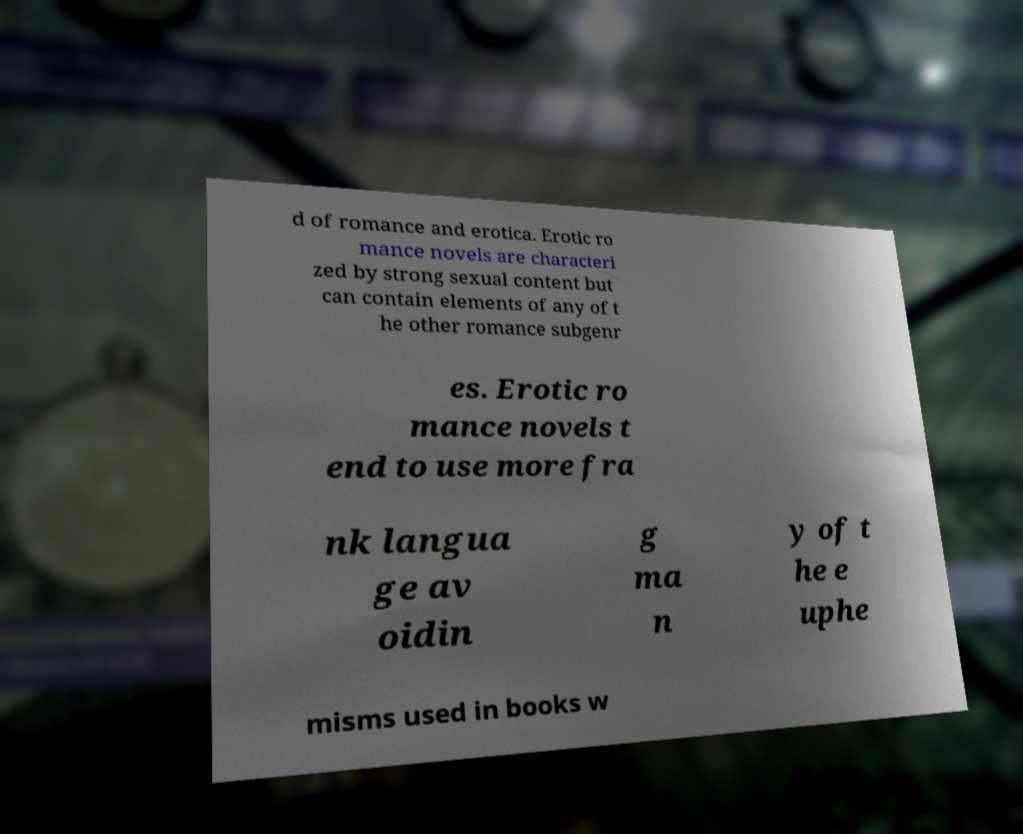Could you assist in decoding the text presented in this image and type it out clearly? d of romance and erotica. Erotic ro mance novels are characteri zed by strong sexual content but can contain elements of any of t he other romance subgenr es. Erotic ro mance novels t end to use more fra nk langua ge av oidin g ma n y of t he e uphe misms used in books w 